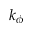Convert formula to latex. <formula><loc_0><loc_0><loc_500><loc_500>k _ { \phi }</formula> 